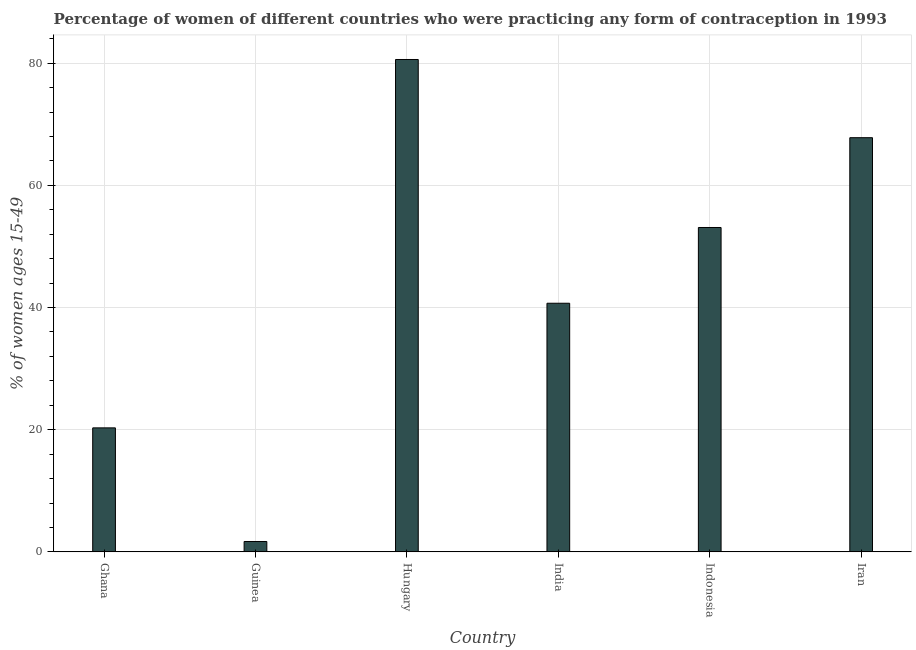What is the title of the graph?
Make the answer very short. Percentage of women of different countries who were practicing any form of contraception in 1993. What is the label or title of the Y-axis?
Offer a very short reply. % of women ages 15-49. What is the contraceptive prevalence in Ghana?
Ensure brevity in your answer.  20.3. Across all countries, what is the maximum contraceptive prevalence?
Keep it short and to the point. 80.6. In which country was the contraceptive prevalence maximum?
Make the answer very short. Hungary. In which country was the contraceptive prevalence minimum?
Your answer should be very brief. Guinea. What is the sum of the contraceptive prevalence?
Keep it short and to the point. 264.2. What is the difference between the contraceptive prevalence in Guinea and Indonesia?
Offer a very short reply. -51.4. What is the average contraceptive prevalence per country?
Make the answer very short. 44.03. What is the median contraceptive prevalence?
Your response must be concise. 46.9. In how many countries, is the contraceptive prevalence greater than 28 %?
Provide a short and direct response. 4. What is the ratio of the contraceptive prevalence in Ghana to that in Guinea?
Your response must be concise. 11.94. Is the contraceptive prevalence in Hungary less than that in Iran?
Your response must be concise. No. Is the difference between the contraceptive prevalence in Ghana and Iran greater than the difference between any two countries?
Give a very brief answer. No. What is the difference between the highest and the second highest contraceptive prevalence?
Give a very brief answer. 12.8. What is the difference between the highest and the lowest contraceptive prevalence?
Provide a succinct answer. 78.9. Are all the bars in the graph horizontal?
Offer a terse response. No. What is the difference between two consecutive major ticks on the Y-axis?
Offer a very short reply. 20. Are the values on the major ticks of Y-axis written in scientific E-notation?
Provide a succinct answer. No. What is the % of women ages 15-49 of Ghana?
Offer a terse response. 20.3. What is the % of women ages 15-49 in Hungary?
Provide a short and direct response. 80.6. What is the % of women ages 15-49 of India?
Your answer should be very brief. 40.7. What is the % of women ages 15-49 of Indonesia?
Offer a terse response. 53.1. What is the % of women ages 15-49 in Iran?
Give a very brief answer. 67.8. What is the difference between the % of women ages 15-49 in Ghana and Hungary?
Offer a terse response. -60.3. What is the difference between the % of women ages 15-49 in Ghana and India?
Your answer should be very brief. -20.4. What is the difference between the % of women ages 15-49 in Ghana and Indonesia?
Ensure brevity in your answer.  -32.8. What is the difference between the % of women ages 15-49 in Ghana and Iran?
Your response must be concise. -47.5. What is the difference between the % of women ages 15-49 in Guinea and Hungary?
Make the answer very short. -78.9. What is the difference between the % of women ages 15-49 in Guinea and India?
Make the answer very short. -39. What is the difference between the % of women ages 15-49 in Guinea and Indonesia?
Make the answer very short. -51.4. What is the difference between the % of women ages 15-49 in Guinea and Iran?
Offer a very short reply. -66.1. What is the difference between the % of women ages 15-49 in Hungary and India?
Ensure brevity in your answer.  39.9. What is the difference between the % of women ages 15-49 in Hungary and Indonesia?
Your response must be concise. 27.5. What is the difference between the % of women ages 15-49 in India and Iran?
Offer a terse response. -27.1. What is the difference between the % of women ages 15-49 in Indonesia and Iran?
Provide a succinct answer. -14.7. What is the ratio of the % of women ages 15-49 in Ghana to that in Guinea?
Your answer should be compact. 11.94. What is the ratio of the % of women ages 15-49 in Ghana to that in Hungary?
Ensure brevity in your answer.  0.25. What is the ratio of the % of women ages 15-49 in Ghana to that in India?
Provide a succinct answer. 0.5. What is the ratio of the % of women ages 15-49 in Ghana to that in Indonesia?
Ensure brevity in your answer.  0.38. What is the ratio of the % of women ages 15-49 in Ghana to that in Iran?
Your response must be concise. 0.3. What is the ratio of the % of women ages 15-49 in Guinea to that in Hungary?
Keep it short and to the point. 0.02. What is the ratio of the % of women ages 15-49 in Guinea to that in India?
Offer a terse response. 0.04. What is the ratio of the % of women ages 15-49 in Guinea to that in Indonesia?
Your response must be concise. 0.03. What is the ratio of the % of women ages 15-49 in Guinea to that in Iran?
Keep it short and to the point. 0.03. What is the ratio of the % of women ages 15-49 in Hungary to that in India?
Your answer should be compact. 1.98. What is the ratio of the % of women ages 15-49 in Hungary to that in Indonesia?
Your answer should be compact. 1.52. What is the ratio of the % of women ages 15-49 in Hungary to that in Iran?
Provide a succinct answer. 1.19. What is the ratio of the % of women ages 15-49 in India to that in Indonesia?
Your response must be concise. 0.77. What is the ratio of the % of women ages 15-49 in India to that in Iran?
Provide a succinct answer. 0.6. What is the ratio of the % of women ages 15-49 in Indonesia to that in Iran?
Provide a short and direct response. 0.78. 